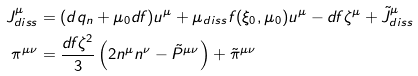<formula> <loc_0><loc_0><loc_500><loc_500>J ^ { \mu } _ { d i s s } & = ( d q _ { n } + \mu _ { 0 } d f ) u ^ { \mu } + \mu _ { d i s s } f ( \xi _ { 0 } , \mu _ { 0 } ) u ^ { \mu } - d f \zeta ^ { \mu } + \tilde { J } ^ { \mu } _ { d i s s } \\ \pi ^ { \mu \nu } & = \frac { d f \zeta ^ { 2 } } { 3 } \left ( 2 n ^ { \mu } n ^ { \nu } - \tilde { P } ^ { \mu \nu } \right ) + { \tilde { \pi } } ^ { \mu \nu }</formula> 